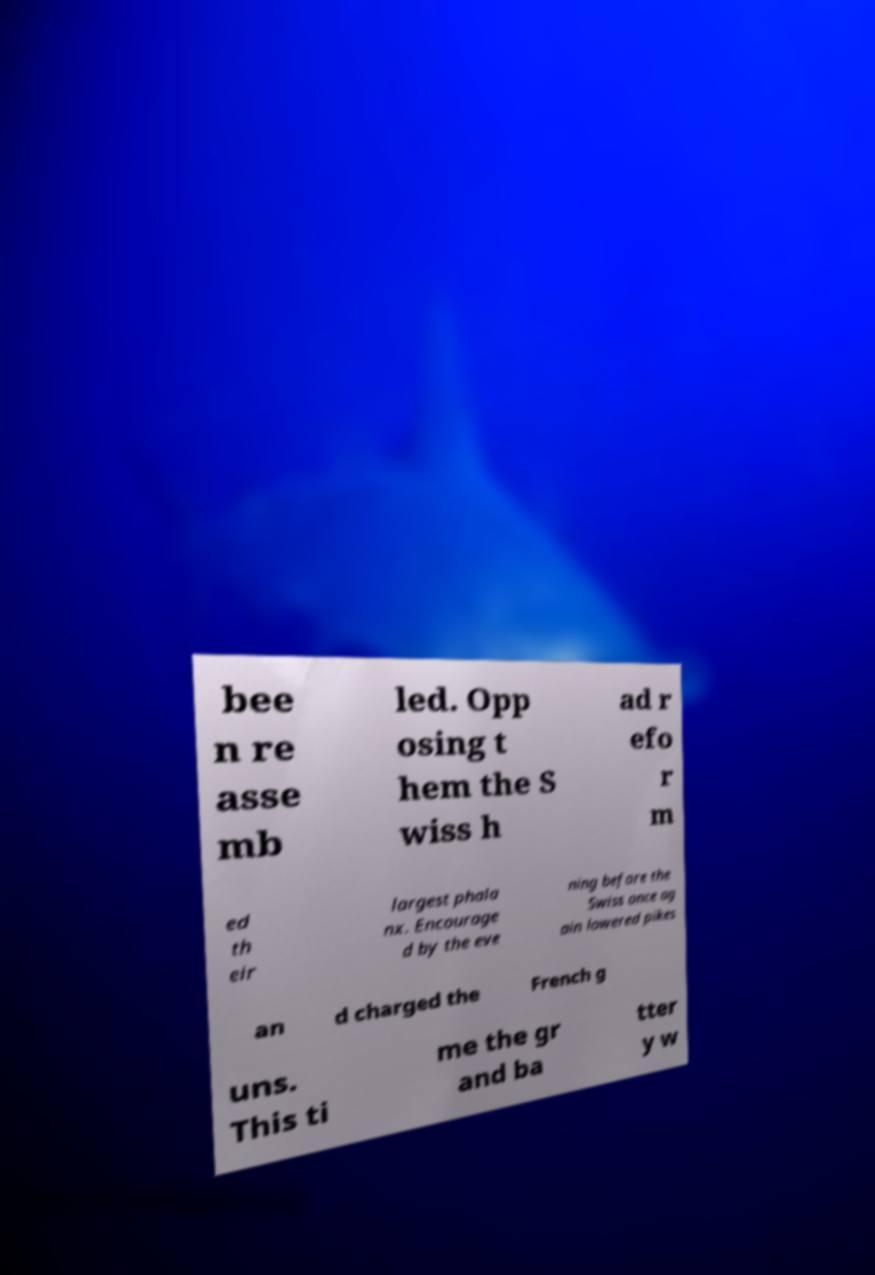I need the written content from this picture converted into text. Can you do that? bee n re asse mb led. Opp osing t hem the S wiss h ad r efo r m ed th eir largest phala nx. Encourage d by the eve ning before the Swiss once ag ain lowered pikes an d charged the French g uns. This ti me the gr and ba tter y w 